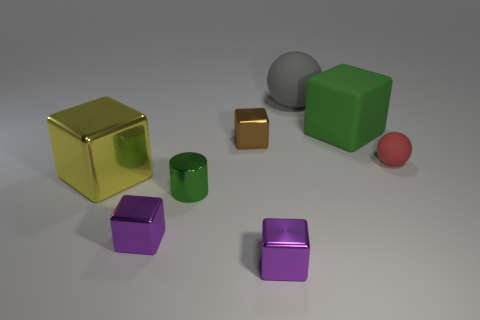Subtract all brown cubes. How many cubes are left? 4 Subtract all green blocks. How many blocks are left? 4 Subtract all yellow blocks. Subtract all yellow cylinders. How many blocks are left? 4 Add 1 small objects. How many objects exist? 9 Subtract all cylinders. How many objects are left? 7 Add 2 tiny green matte things. How many tiny green matte things exist? 2 Subtract 0 blue blocks. How many objects are left? 8 Subtract all tiny brown matte things. Subtract all gray rubber things. How many objects are left? 7 Add 1 small green things. How many small green things are left? 2 